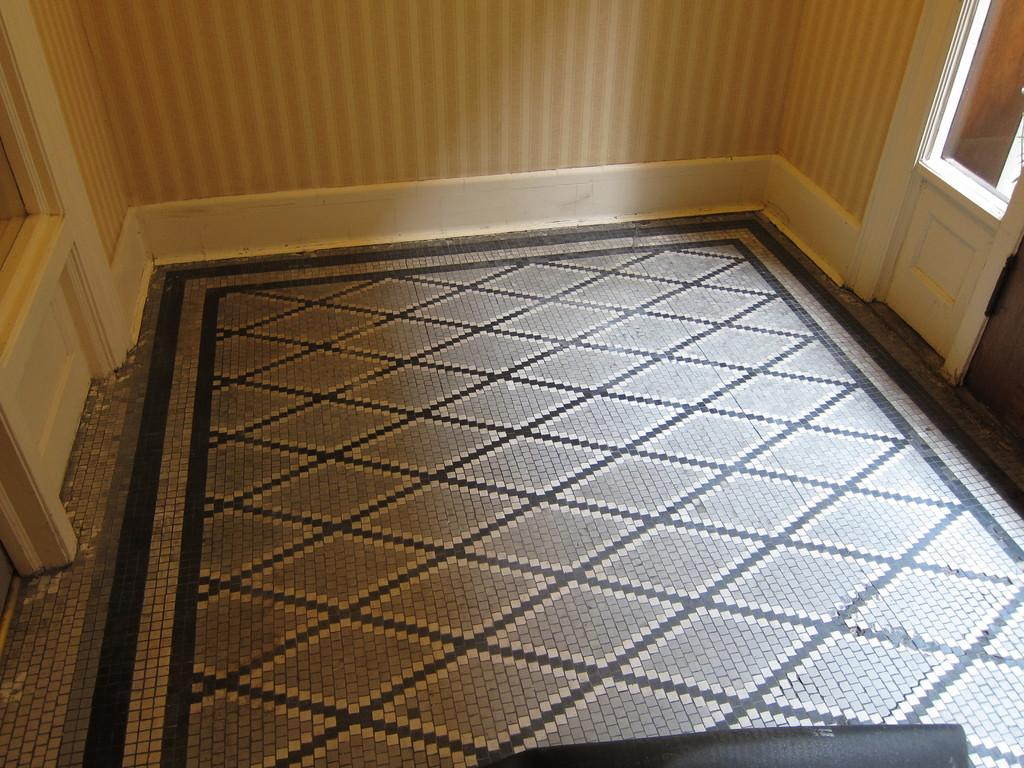What is at the bottom of the image? There is a floor at the bottom of the image. What can be seen in the background of the image? There is a wall and a window in the background of the image. How many lizards can be seen crawling on the floor in the image? There are no lizards present in the image; it only features a floor, a wall, and a window. Can you tell me how many people are walking on the floor in the image? There is no indication of people walking on the floor in the image. 